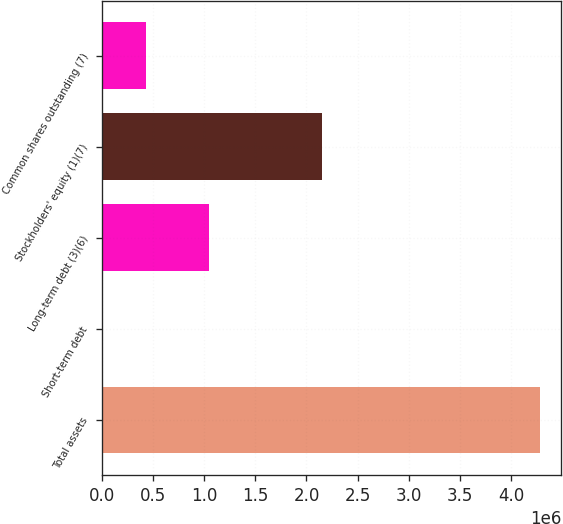<chart> <loc_0><loc_0><loc_500><loc_500><bar_chart><fcel>Total assets<fcel>Short-term debt<fcel>Long-term debt (3)(6)<fcel>Stockholders' equity (1)(7)<fcel>Common shares outstanding (7)<nl><fcel>4.27668e+06<fcel>1172<fcel>1.04525e+06<fcel>2.15357e+06<fcel>428723<nl></chart> 